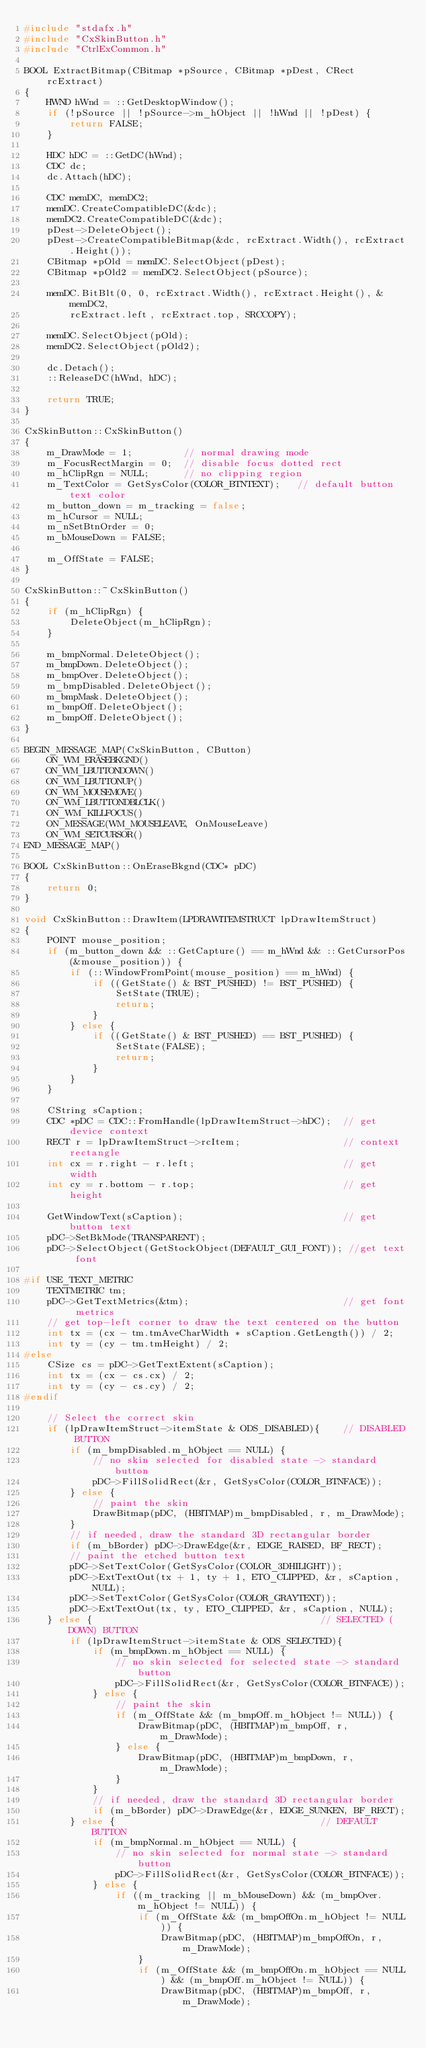Convert code to text. <code><loc_0><loc_0><loc_500><loc_500><_C++_>#include "stdafx.h"
#include "CxSkinButton.h"
#include "CtrlExCommon.h"

BOOL ExtractBitmap(CBitmap *pSource, CBitmap *pDest, CRect rcExtract)
{
	HWND hWnd = ::GetDesktopWindow();
	if (!pSource || !pSource->m_hObject || !hWnd || !pDest) {
		return FALSE;
	}

	HDC hDC = ::GetDC(hWnd);
	CDC dc;
	dc.Attach(hDC);

	CDC memDC, memDC2;
	memDC.CreateCompatibleDC(&dc);
	memDC2.CreateCompatibleDC(&dc);
	pDest->DeleteObject();
	pDest->CreateCompatibleBitmap(&dc, rcExtract.Width(), rcExtract.Height());
	CBitmap *pOld = memDC.SelectObject(pDest);
	CBitmap *pOld2 = memDC2.SelectObject(pSource);

	memDC.BitBlt(0, 0, rcExtract.Width(), rcExtract.Height(), &memDC2,
		rcExtract.left, rcExtract.top, SRCCOPY);

	memDC.SelectObject(pOld);
	memDC2.SelectObject(pOld2);

	dc.Detach();
	::ReleaseDC(hWnd, hDC);

	return TRUE;
}

CxSkinButton::CxSkinButton()
{
	m_DrawMode = 1;			// normal drawing mode
	m_FocusRectMargin = 0;	// disable focus dotted rect
	m_hClipRgn = NULL;		// no clipping region
	m_TextColor = GetSysColor(COLOR_BTNTEXT);	// default button text color
	m_button_down = m_tracking = false;
	m_hCursor = NULL;
	m_nSetBtnOrder = 0;
	m_bMouseDown = FALSE;

	m_OffState = FALSE;
}

CxSkinButton::~CxSkinButton()
{
	if (m_hClipRgn) {
		DeleteObject(m_hClipRgn);
	}

	m_bmpNormal.DeleteObject();
	m_bmpDown.DeleteObject();
	m_bmpOver.DeleteObject();
	m_bmpDisabled.DeleteObject();
	m_bmpMask.DeleteObject();
	m_bmpOff.DeleteObject();
	m_bmpOff.DeleteObject();
}

BEGIN_MESSAGE_MAP(CxSkinButton, CButton)
	ON_WM_ERASEBKGND()
	ON_WM_LBUTTONDOWN()
	ON_WM_LBUTTONUP()
	ON_WM_MOUSEMOVE()
	ON_WM_LBUTTONDBLCLK()
	ON_WM_KILLFOCUS()
	ON_MESSAGE(WM_MOUSELEAVE, OnMouseLeave)
	ON_WM_SETCURSOR()
END_MESSAGE_MAP()

BOOL CxSkinButton::OnEraseBkgnd(CDC* pDC) 
{
	return 0;
}

void CxSkinButton::DrawItem(LPDRAWITEMSTRUCT lpDrawItemStruct) 
{
	POINT mouse_position;
	if (m_button_down && ::GetCapture() == m_hWnd && ::GetCursorPos(&mouse_position)) {
		if (::WindowFromPoint(mouse_position) == m_hWnd) {
			if ((GetState() & BST_PUSHED) != BST_PUSHED) {
				SetState(TRUE);
				return;
			}
		} else {
			if ((GetState() & BST_PUSHED) == BST_PUSHED) {
				SetState(FALSE);
				return;
			}
		}
	}

	CString sCaption;
	CDC *pDC = CDC::FromHandle(lpDrawItemStruct->hDC);	// get device context
	RECT r = lpDrawItemStruct->rcItem;					// context rectangle
	int cx = r.right - r.left;							// get width
	int cy = r.bottom - r.top;							// get height

	GetWindowText(sCaption);							// get button text
	pDC->SetBkMode(TRANSPARENT);
	pDC->SelectObject(GetStockObject(DEFAULT_GUI_FONT)); //get text font

#if USE_TEXT_METRIC
	TEXTMETRIC tm;
	pDC->GetTextMetrics(&tm);							// get font metrics
	// get top-left corner to draw the text centered on the button
	int tx = (cx - tm.tmAveCharWidth * sCaption.GetLength()) / 2;
	int ty = (cy - tm.tmHeight) / 2;
#else
	CSize cs = pDC->GetTextExtent(sCaption);
	int tx = (cx - cs.cx) / 2;
	int ty = (cy - cs.cy) / 2;
#endif

	// Select the correct skin 
	if (lpDrawItemStruct->itemState & ODS_DISABLED){	// DISABLED BUTTON
		if (m_bmpDisabled.m_hObject == NULL) {
			// no skin selected for disabled state -> standard button
			pDC->FillSolidRect(&r, GetSysColor(COLOR_BTNFACE));
		} else {
			// paint the skin
			DrawBitmap(pDC, (HBITMAP)m_bmpDisabled, r, m_DrawMode);
		}
		// if needed, draw the standard 3D rectangular border
		if (m_bBorder) pDC->DrawEdge(&r, EDGE_RAISED, BF_RECT);
		// paint the etched button text
		pDC->SetTextColor(GetSysColor(COLOR_3DHILIGHT));
		pDC->ExtTextOut(tx + 1, ty + 1, ETO_CLIPPED, &r, sCaption, NULL);
		pDC->SetTextColor(GetSysColor(COLOR_GRAYTEXT));
		pDC->ExtTextOut(tx, ty, ETO_CLIPPED, &r, sCaption, NULL);
	} else {										// SELECTED (DOWN) BUTTON
		if (lpDrawItemStruct->itemState & ODS_SELECTED){
			if (m_bmpDown.m_hObject == NULL) {
				// no skin selected for selected state -> standard button
				pDC->FillSolidRect(&r, GetSysColor(COLOR_BTNFACE));
			} else {
				// paint the skin
				if (m_OffState && (m_bmpOff.m_hObject != NULL)) {
					DrawBitmap(pDC, (HBITMAP)m_bmpOff, r, m_DrawMode);
				} else {
					DrawBitmap(pDC, (HBITMAP)m_bmpDown, r, m_DrawMode);
				}
			}
			// if needed, draw the standard 3D rectangular border
			if (m_bBorder) pDC->DrawEdge(&r, EDGE_SUNKEN, BF_RECT);
		} else {									// DEFAULT BUTTON
			if (m_bmpNormal.m_hObject == NULL) {
				// no skin selected for normal state -> standard button
				pDC->FillSolidRect(&r, GetSysColor(COLOR_BTNFACE));
			} else {
				if ((m_tracking || m_bMouseDown) && (m_bmpOver.m_hObject != NULL)) {
					if (m_OffState && (m_bmpOffOn.m_hObject != NULL)) {
						DrawBitmap(pDC, (HBITMAP)m_bmpOffOn, r, m_DrawMode);
					}
					if (m_OffState && (m_bmpOffOn.m_hObject == NULL) && (m_bmpOff.m_hObject != NULL)) {
						DrawBitmap(pDC, (HBITMAP)m_bmpOff, r, m_DrawMode);</code> 